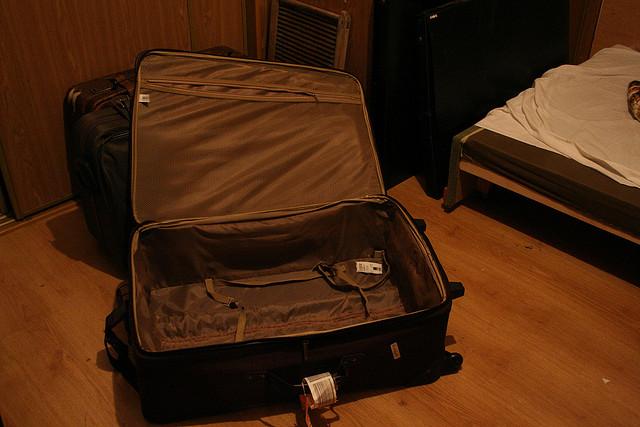Is someone moving away?
Quick response, please. No. Is a rug present?
Be succinct. No. Is this suitcase packed?
Quick response, please. No. How old do you think are these suitcases?
Answer briefly. Not very old. Where are the bags?
Be succinct. Floor. What color is the luggage tag?
Keep it brief. White. Is there anything alive?
Answer briefly. No. What material are the suitcases made of?
Write a very short answer. Nylon. Are there Kleenex visible?
Keep it brief. No. Does the suitcase look beat up?
Quick response, please. No. How many suitcases are shown?
Give a very brief answer. 2. Are the suitcases black?
Quick response, please. Yes. Where are the straps on the suitcase?
Write a very short answer. Inside. What color is the outside of this luggage?
Short answer required. Black. Is there a lot of clutter in this space?
Quick response, please. No. How many hard suitcases that are blue are there?
Concise answer only. 0. How many pairs of shoes are under the bed?
Write a very short answer. 0. Is the suitcase empty?
Quick response, please. Yes. Is there a book in the suitcase?
Keep it brief. No. Is the suitcase full?
Be succinct. No. What's in the suitcase?
Concise answer only. Nothing. Is there a purse in the suitcase?
Short answer required. No. Could someone come along and steal this bag?
Concise answer only. No. Where these bags on an airplane?
Short answer required. Yes. Does the suitcase look empty?
Keep it brief. Yes. Are there jeans in the bag?
Keep it brief. No. Are the trunks full?
Short answer required. No. Is the suitcase sitting on the floor?
Answer briefly. Yes. What kind of clothes are in the suitcase?
Give a very brief answer. None. What color is the suitcase?
Keep it brief. Black. Is this suitcase full?
Answer briefly. No. Is the floor finished?
Answer briefly. Yes. How many suitcases in the photo?
Give a very brief answer. 2. 